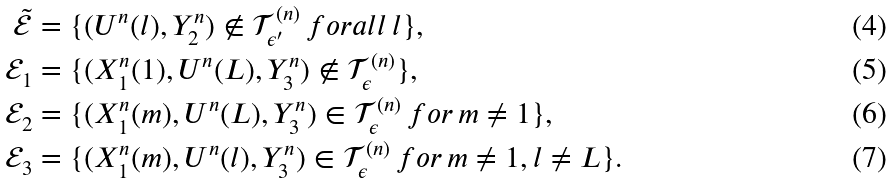Convert formula to latex. <formula><loc_0><loc_0><loc_500><loc_500>\tilde { \mathcal { E } } & = \{ ( U ^ { n } ( l ) , Y _ { 2 } ^ { n } ) \notin \mathcal { T } _ { \epsilon ^ { \prime } } ^ { ( n ) } \, f o r a l l \, l \} , \\ \mathcal { E } _ { 1 } & = \{ ( X _ { 1 } ^ { n } ( 1 ) , U ^ { n } ( L ) , Y _ { 3 } ^ { n } ) \notin \mathcal { T } _ { \epsilon } ^ { ( n ) } \} , \\ \mathcal { E } _ { 2 } & = \{ ( X _ { 1 } ^ { n } ( m ) , U ^ { n } ( L ) , Y _ { 3 } ^ { n } ) \in \mathcal { T } _ { \epsilon } ^ { ( n ) } \, f o r \, m \neq 1 \} , \\ \mathcal { E } _ { 3 } & = \{ ( X _ { 1 } ^ { n } ( m ) , U ^ { n } ( l ) , Y _ { 3 } ^ { n } ) \in \mathcal { T } _ { \epsilon } ^ { ( n ) } \, f o r \, m \neq 1 , l \neq L \} .</formula> 